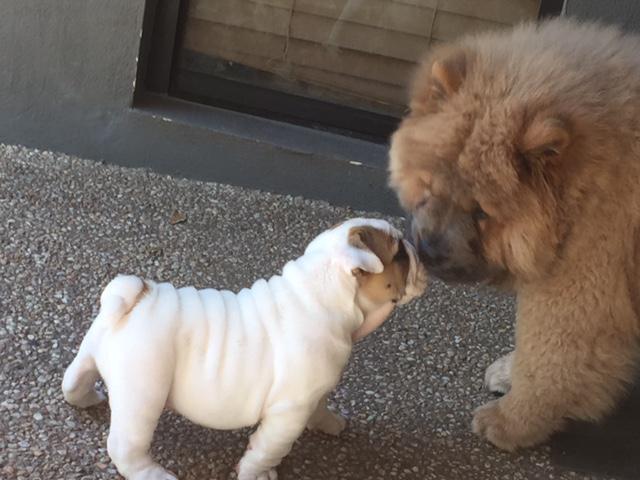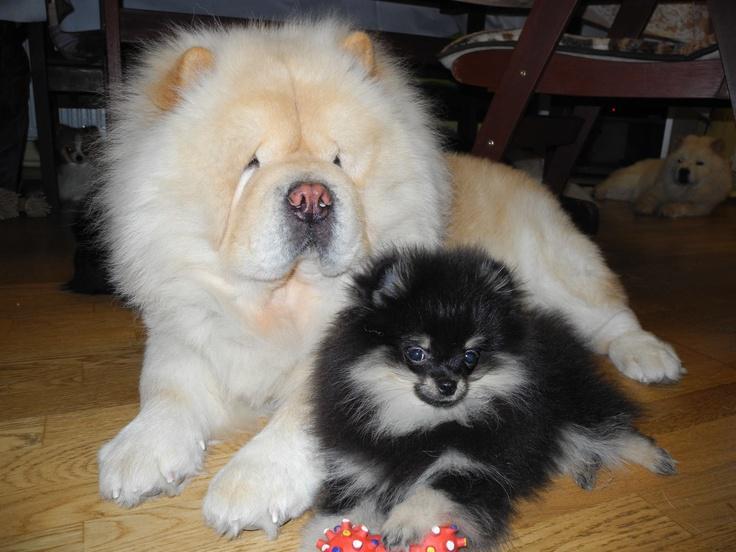The first image is the image on the left, the second image is the image on the right. For the images displayed, is the sentence "In one image of a chow dog, a human leg in jeans is visible." factually correct? Answer yes or no. No. The first image is the image on the left, the second image is the image on the right. Assess this claim about the two images: "Two dogs are sitting together in one of the images.". Correct or not? Answer yes or no. Yes. 